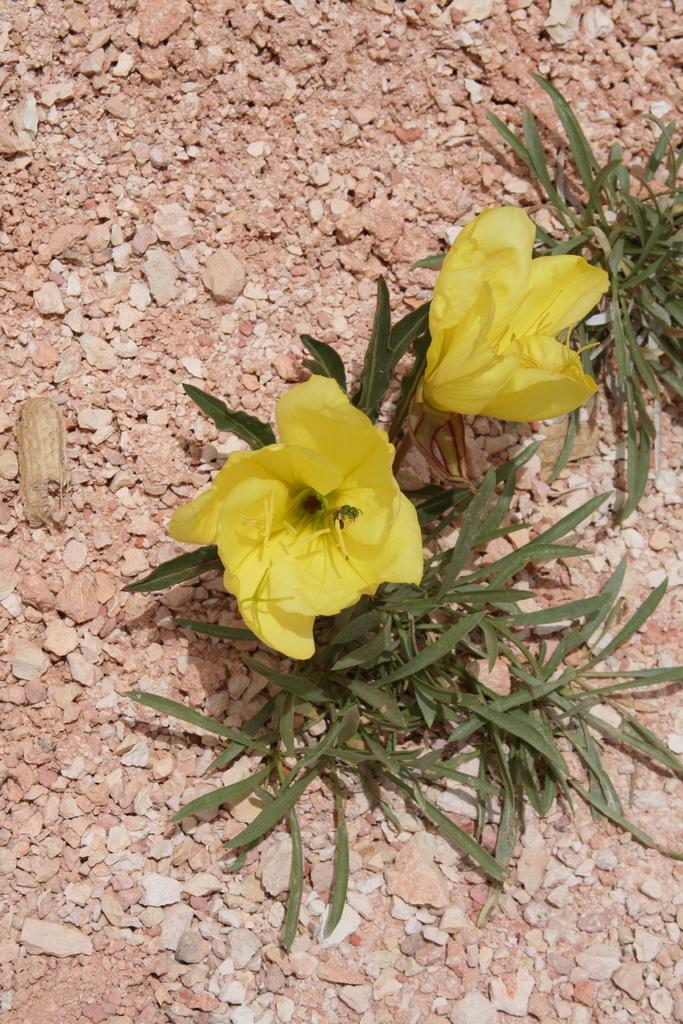Can you describe this image briefly? There are yellow color flowers and leaves on the stones texture. 